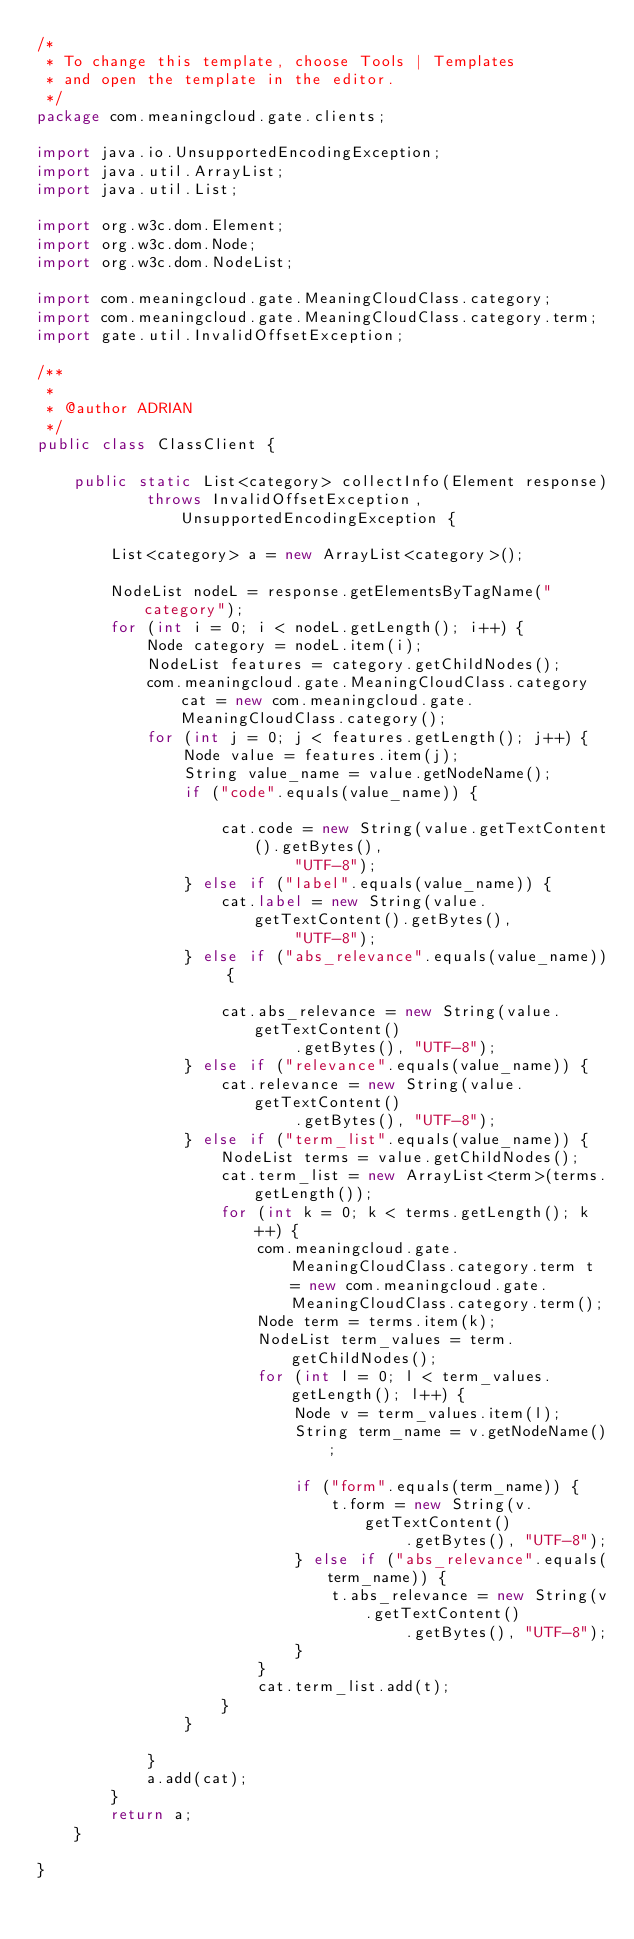Convert code to text. <code><loc_0><loc_0><loc_500><loc_500><_Java_>/*
 * To change this template, choose Tools | Templates
 * and open the template in the editor.
 */
package com.meaningcloud.gate.clients;

import java.io.UnsupportedEncodingException;
import java.util.ArrayList;
import java.util.List;

import org.w3c.dom.Element;
import org.w3c.dom.Node;
import org.w3c.dom.NodeList;

import com.meaningcloud.gate.MeaningCloudClass.category;
import com.meaningcloud.gate.MeaningCloudClass.category.term;
import gate.util.InvalidOffsetException;

/**
 *
 * @author ADRIAN
 */
public class ClassClient {

	public static List<category> collectInfo(Element response)
			throws InvalidOffsetException, UnsupportedEncodingException {

		List<category> a = new ArrayList<category>();

		NodeList nodeL = response.getElementsByTagName("category");
		for (int i = 0; i < nodeL.getLength(); i++) {
			Node category = nodeL.item(i);
			NodeList features = category.getChildNodes();
			com.meaningcloud.gate.MeaningCloudClass.category cat = new com.meaningcloud.gate.MeaningCloudClass.category();
			for (int j = 0; j < features.getLength(); j++) {
				Node value = features.item(j);
				String value_name = value.getNodeName();
				if ("code".equals(value_name)) {

					cat.code = new String(value.getTextContent().getBytes(),
							"UTF-8");
				} else if ("label".equals(value_name)) {
					cat.label = new String(value.getTextContent().getBytes(),
							"UTF-8");
				} else if ("abs_relevance".equals(value_name)) {

					cat.abs_relevance = new String(value.getTextContent()
							.getBytes(), "UTF-8");
				} else if ("relevance".equals(value_name)) {
					cat.relevance = new String(value.getTextContent()
							.getBytes(), "UTF-8");
				} else if ("term_list".equals(value_name)) {
					NodeList terms = value.getChildNodes();
					cat.term_list = new ArrayList<term>(terms.getLength());
					for (int k = 0; k < terms.getLength(); k++) {
						com.meaningcloud.gate.MeaningCloudClass.category.term t = new com.meaningcloud.gate.MeaningCloudClass.category.term();
						Node term = terms.item(k);
						NodeList term_values = term.getChildNodes();
						for (int l = 0; l < term_values.getLength(); l++) {
							Node v = term_values.item(l);
							String term_name = v.getNodeName();

							if ("form".equals(term_name)) {
								t.form = new String(v.getTextContent()
										.getBytes(), "UTF-8");
							} else if ("abs_relevance".equals(term_name)) {
								t.abs_relevance = new String(v.getTextContent()
										.getBytes(), "UTF-8");
							}
						}
						cat.term_list.add(t);
					}
				}

			}
			a.add(cat);
		}
		return a;
	}

}
</code> 